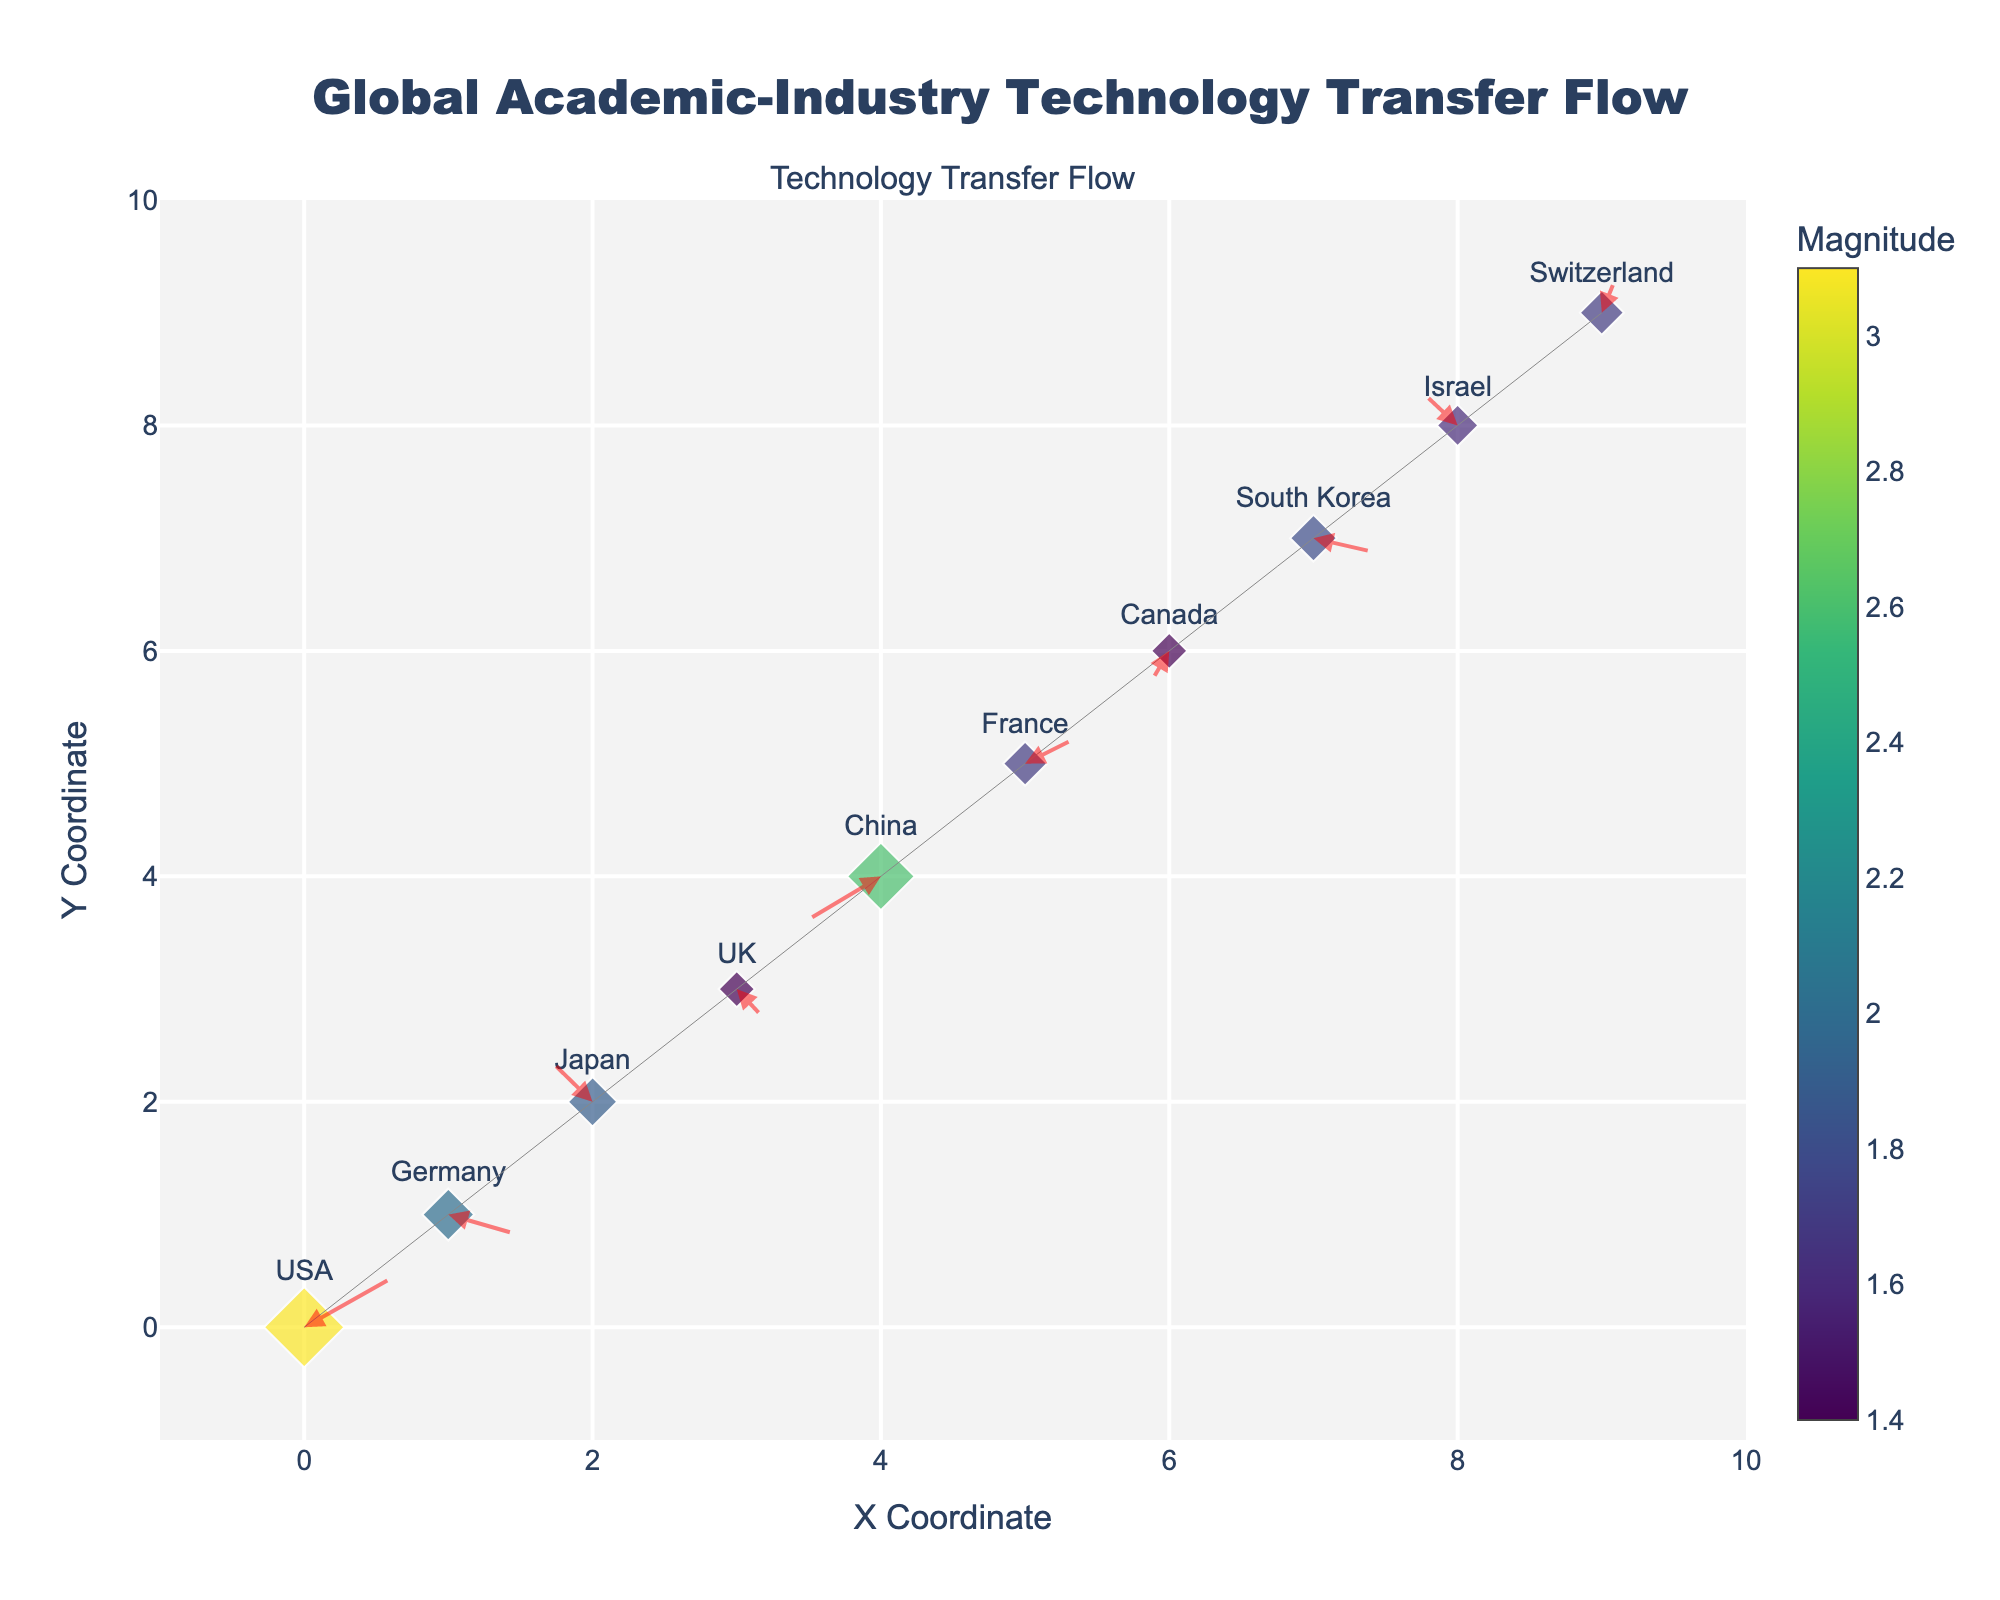What's the title of the figure? The title is typically displayed centrally at the top of the figure, indicating the main theme or subject. In this case, the title is "Global Academic-Industry Technology Transfer Flow".
Answer: Global Academic-Industry Technology Transfer Flow What is the color scale used for the marker sizes, and what does it represent? The color scale used is 'Viridis', and it represents the Magnitude of technology transfers, which is indicated by the associated color bar titled "Magnitude" next to the figure.
Answer: Viridis, Magnitude Which country has the highest magnitude of technology transfer? The country with the highest magnitude is indicated by the largest marker in size. By examining the plot, we see that the USA has the largest marker.
Answer: USA How many arrows are there on the plot? Each data point seems to have one arrow associated with it. Since there are 10 data points, as there are 10 rows in the data, there are 10 arrows.
Answer: 10 Which country shows a negative Y component in its technology transfer flow vector? A negative Y component means the V value is negative. By examining the hover text for the different points, we see that Germany, UK, China, and Canada have negative V values.
Answer: Germany, UK, China, Canada What is the x-axis range of the plot? The x-axis range is typically displayed on the axis itself or in the axis properties. The plot's x-axis range is from -1 to 10, as indicated by the axis range settings.
Answer: -1 to 10 What is the exact value of the magnitude for Switzerland? By examining the hover text for the Switzerland marker, we can read that the magnitude is 1.7.
Answer: 1.7 Which country has the most outwardly pointed (i.e., away from the origin) flow vector in the X direction, and what is its value? Outwardly pointed flow vectors in the X direction can be identified by the highest positive U value. USA has the highest positive U value of 2.5.
Answer: USA, 2.5 Compare the technology transfer flow vectors of Japan and Israel. Which one has a higher magnitude and in what direction do the arrows point? The hover text or markers indicate that Japan has a magnitude of 1.9 with vectors pointing left and upwards (-1.2, 1.5) and Israel has a magnitude of 1.6 with vectors pointing left and upwards (-1.0, 1.2). Hence, Japan has a higher magnitude.
Answer: Japan, higher Which country exhibits the smallest magnitude, and what does its arrow look like? The country with the smallest magnitude is identified by the smallest marker size. UK has the smallest magnitude of 1.4, and its arrow points right and downwards.
Answer: UK, smallest magnitude 